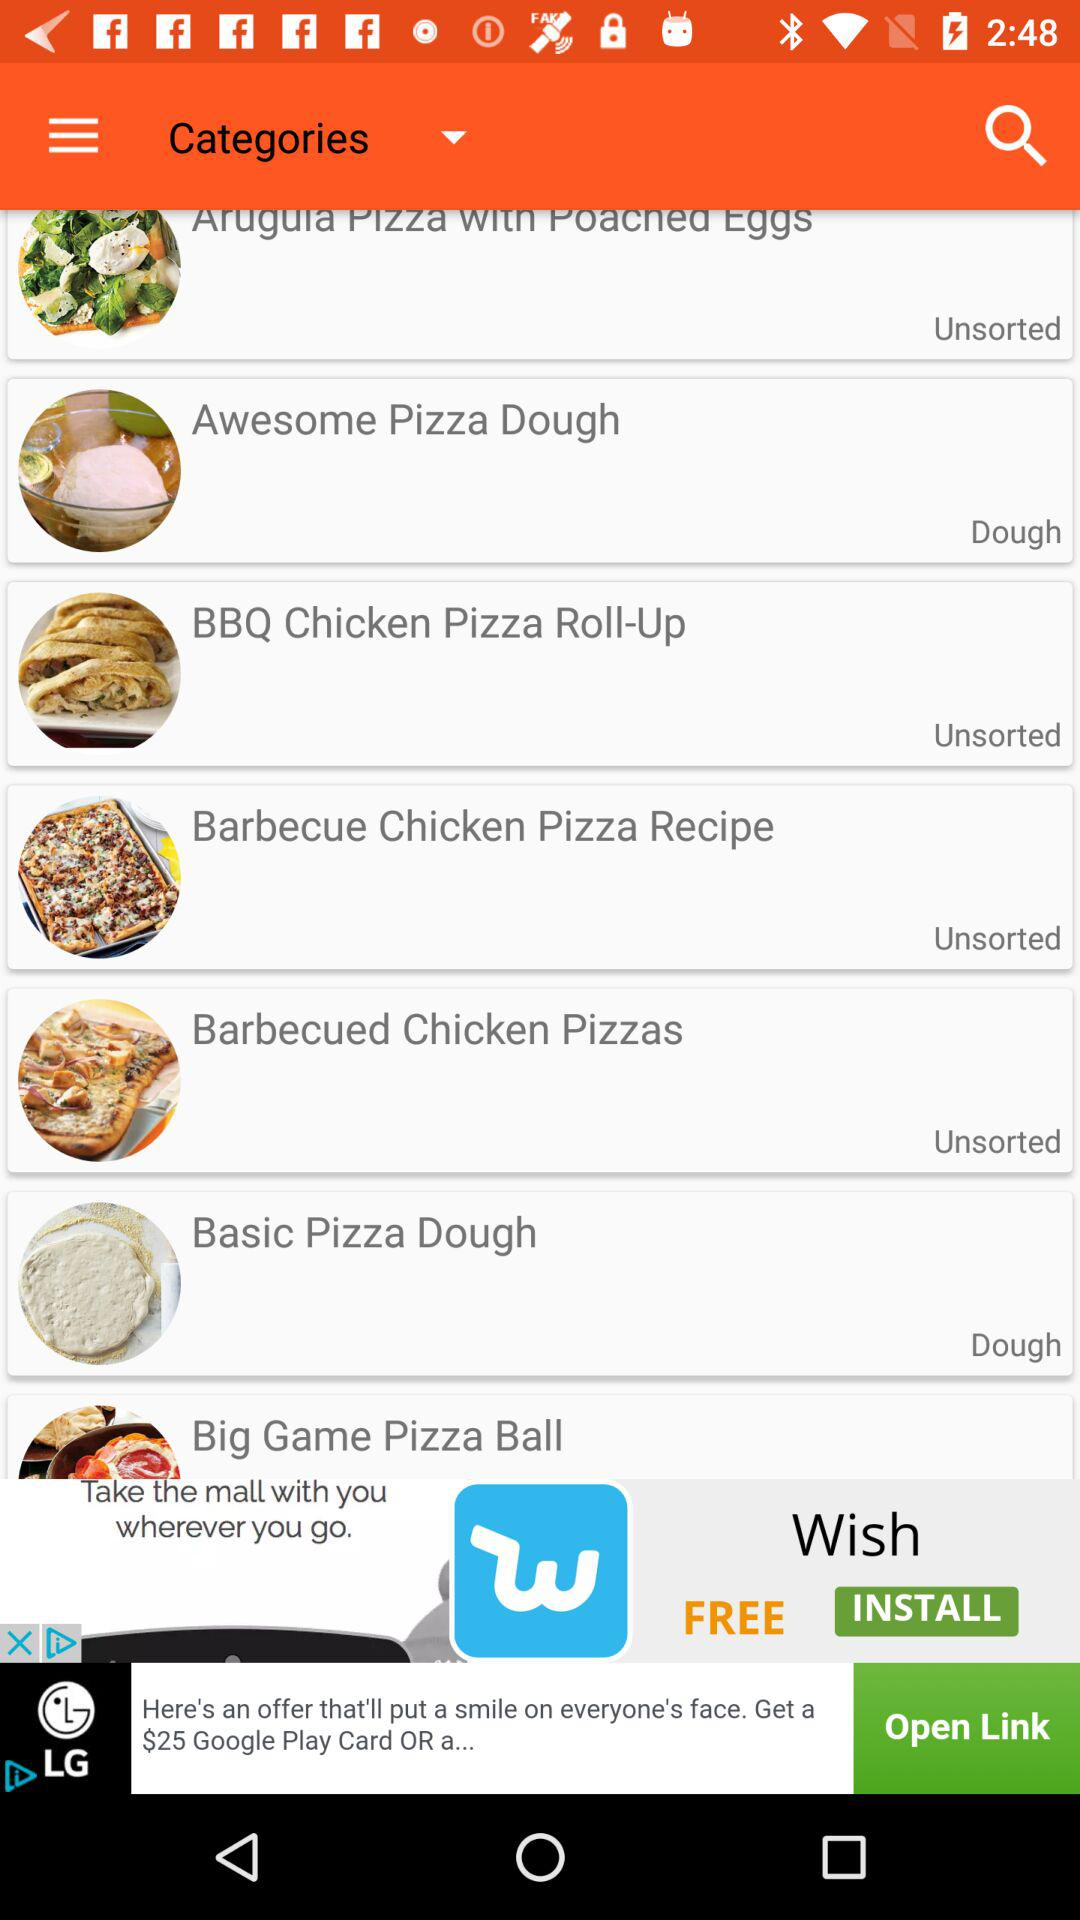How many cups of flour for the awesome pizza dough?
When the provided information is insufficient, respond with <no answer>. <no answer> 